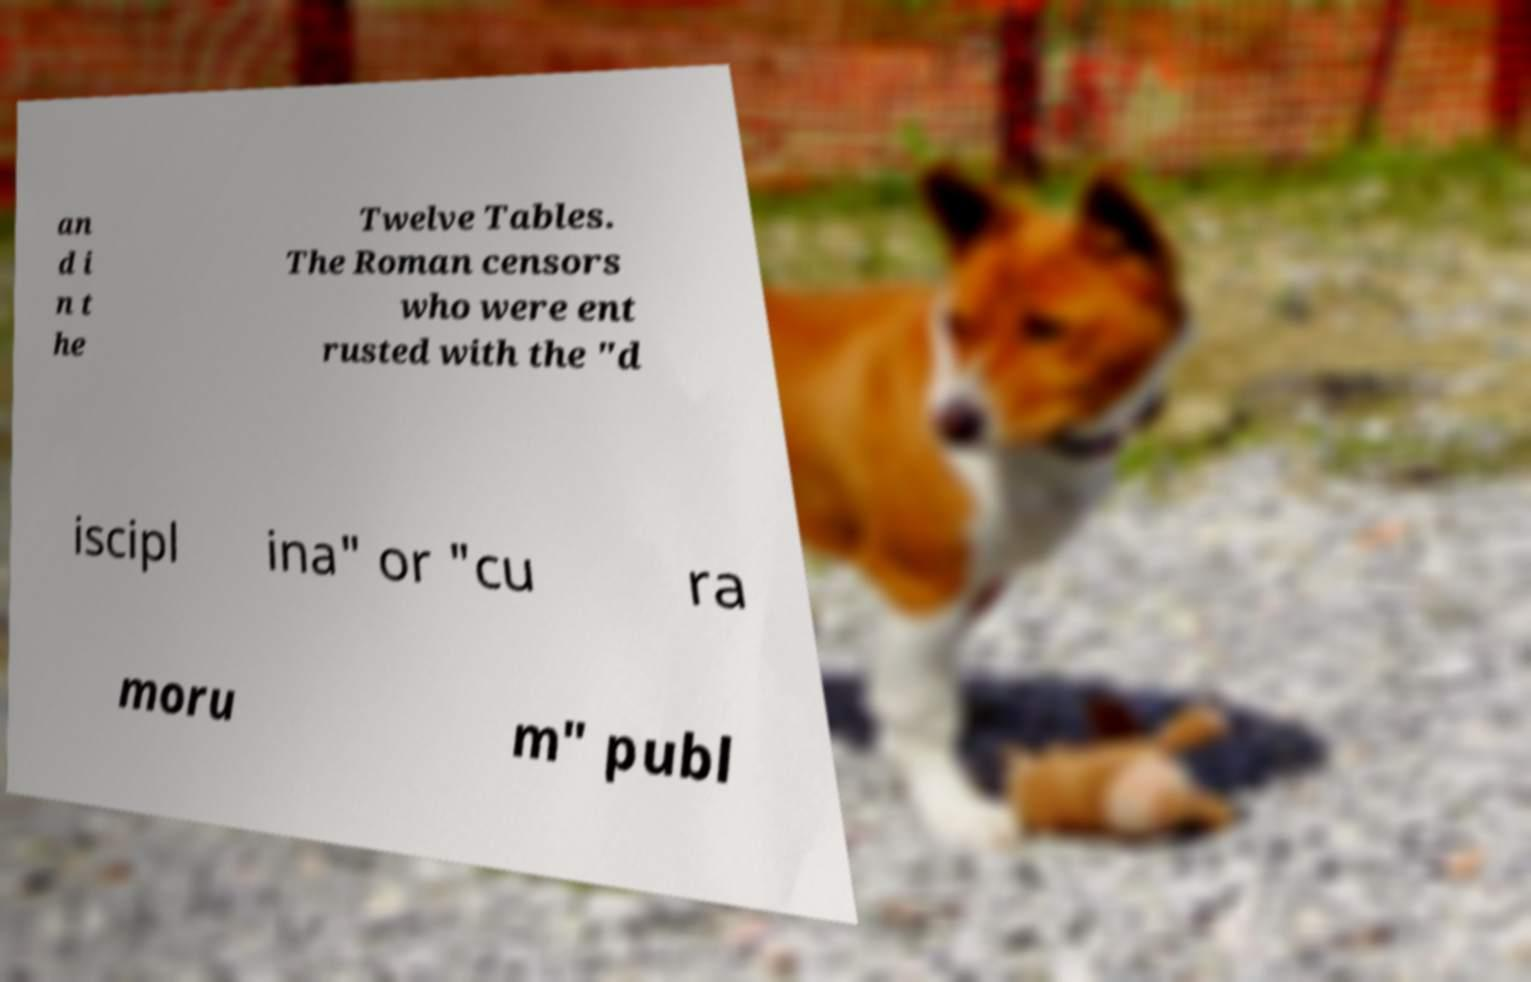Can you read and provide the text displayed in the image?This photo seems to have some interesting text. Can you extract and type it out for me? an d i n t he Twelve Tables. The Roman censors who were ent rusted with the "d iscipl ina" or "cu ra moru m" publ 